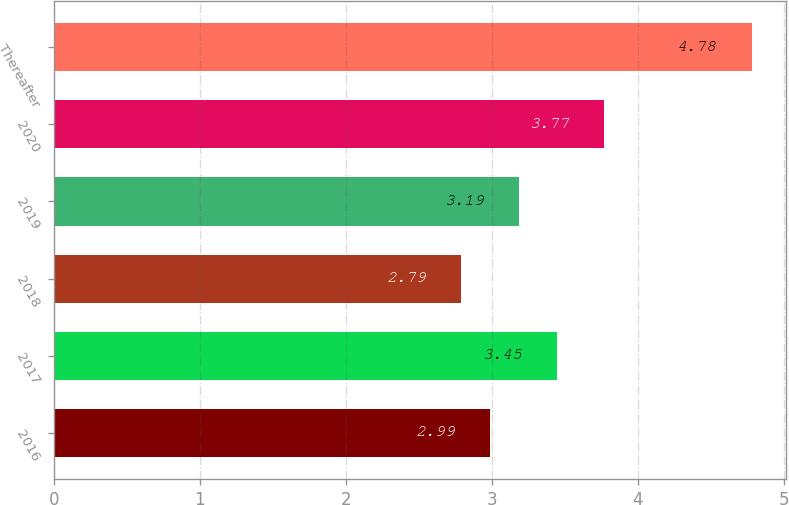<chart> <loc_0><loc_0><loc_500><loc_500><bar_chart><fcel>2016<fcel>2017<fcel>2018<fcel>2019<fcel>2020<fcel>Thereafter<nl><fcel>2.99<fcel>3.45<fcel>2.79<fcel>3.19<fcel>3.77<fcel>4.78<nl></chart> 